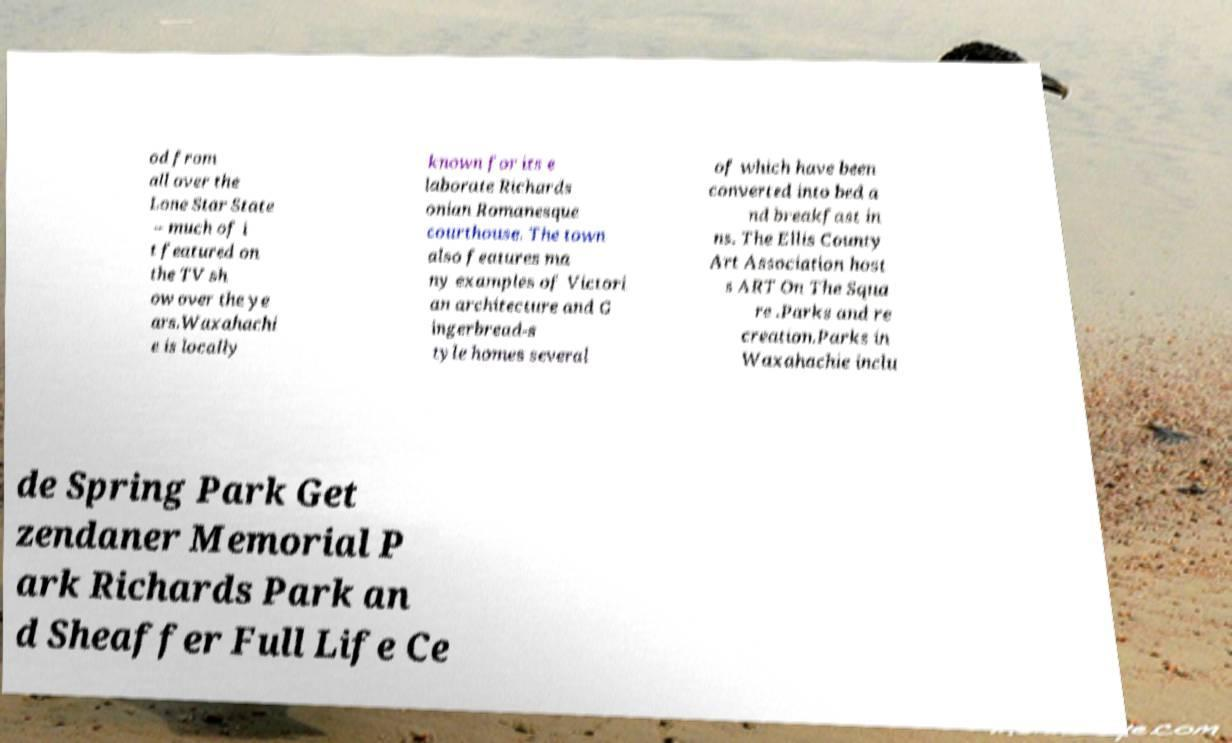Could you extract and type out the text from this image? od from all over the Lone Star State – much of i t featured on the TV sh ow over the ye ars.Waxahachi e is locally known for its e laborate Richards onian Romanesque courthouse. The town also features ma ny examples of Victori an architecture and G ingerbread-s tyle homes several of which have been converted into bed a nd breakfast in ns. The Ellis County Art Association host s ART On The Squa re .Parks and re creation.Parks in Waxahachie inclu de Spring Park Get zendaner Memorial P ark Richards Park an d Sheaffer Full Life Ce 